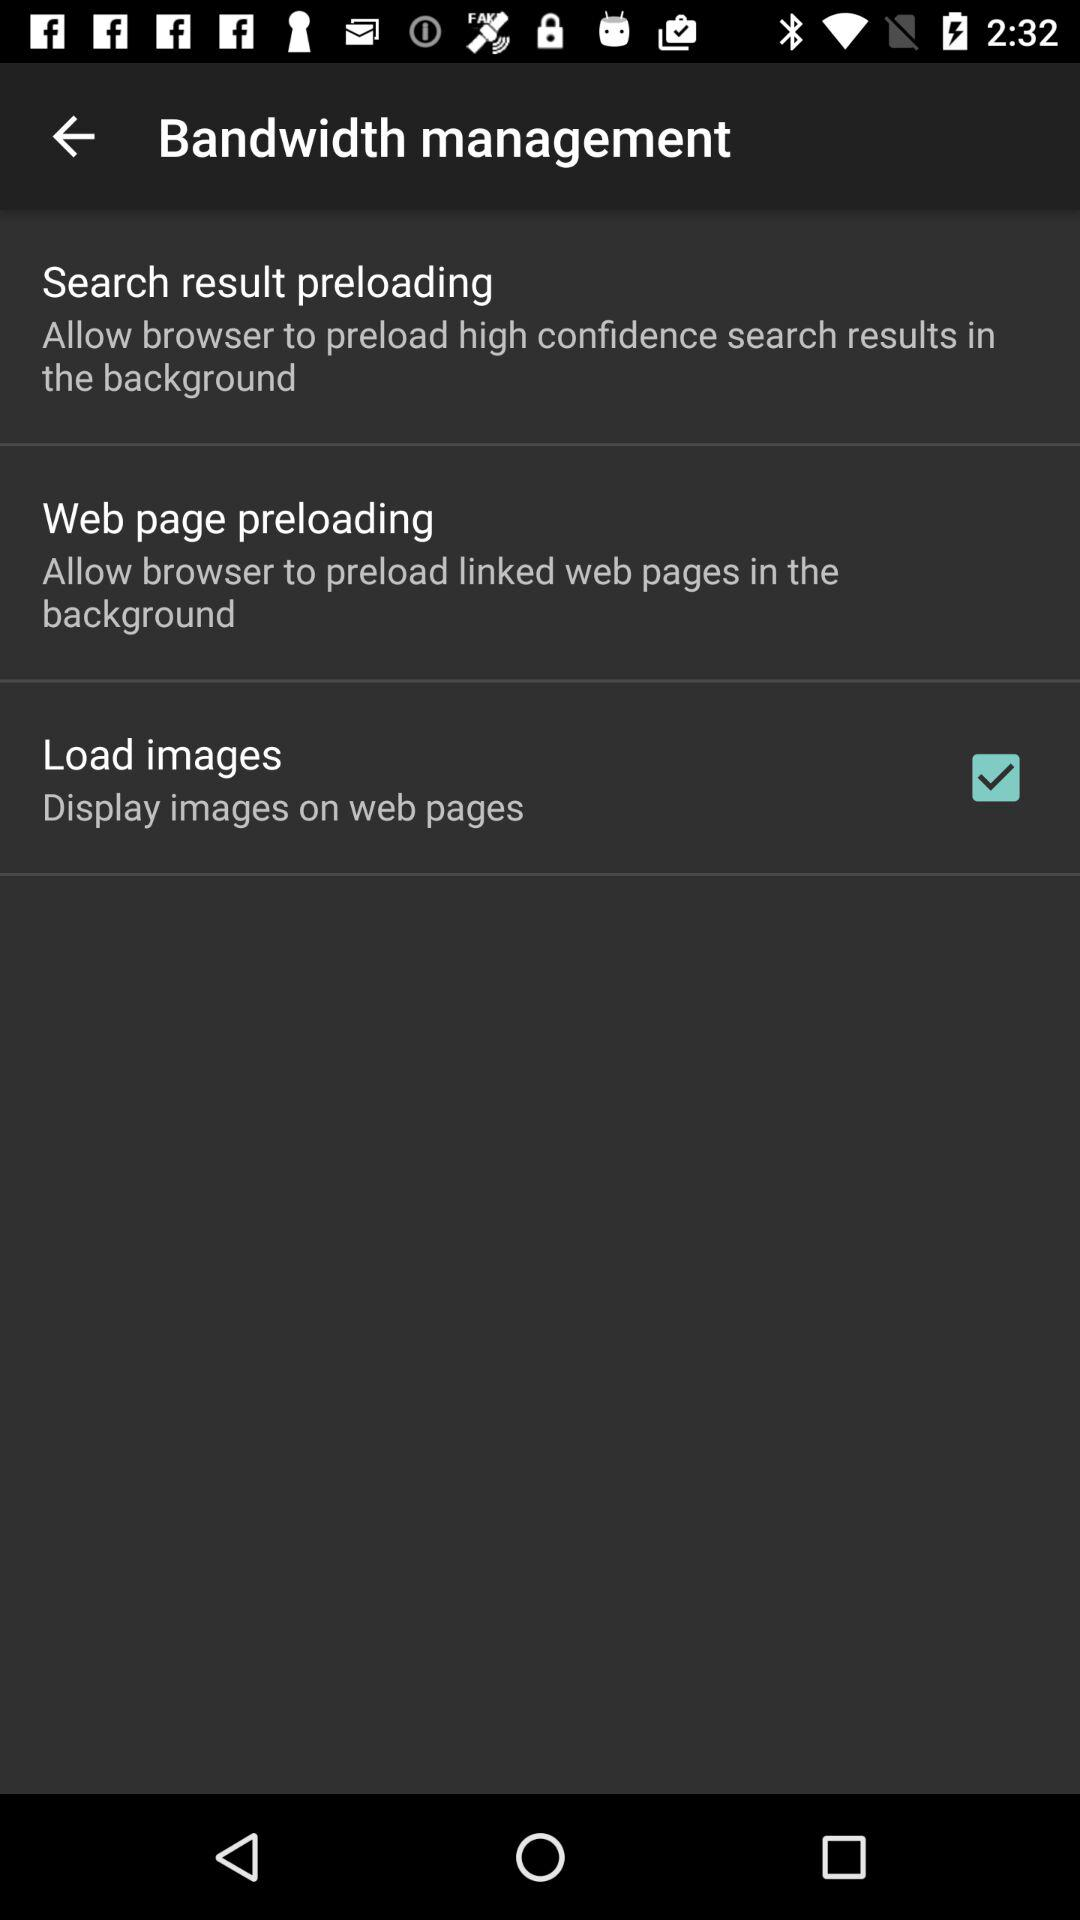How many of the 3 options allow the browser to load content in the background?
Answer the question using a single word or phrase. 2 